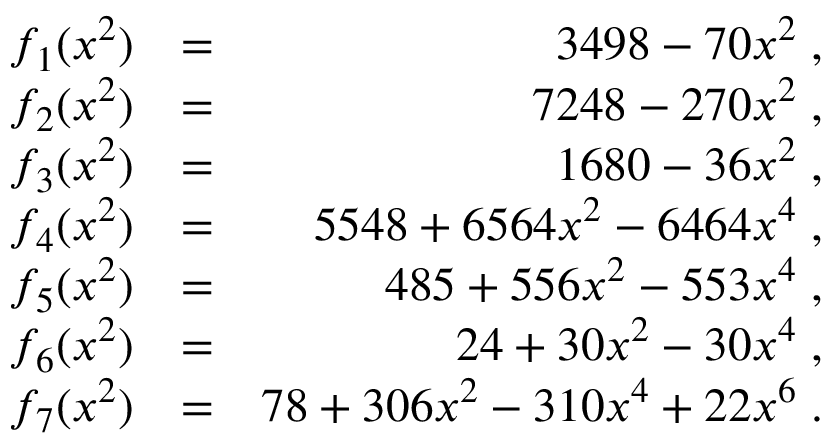<formula> <loc_0><loc_0><loc_500><loc_500>\begin{array} { r l r } { f _ { 1 } ( x ^ { 2 } ) } & { = } & { 3 4 9 8 - 7 0 x ^ { 2 } \, , } \\ { f _ { 2 } ( x ^ { 2 } ) } & { = } & { 7 2 4 8 - 2 7 0 x ^ { 2 } \, , } \\ { f _ { 3 } ( x ^ { 2 } ) } & { = } & { 1 6 8 0 - 3 6 x ^ { 2 } \, , } \\ { f _ { 4 } ( x ^ { 2 } ) } & { = } & { 5 5 4 8 + 6 5 6 4 x ^ { 2 } - 6 4 6 4 x ^ { 4 } \, , } \\ { f _ { 5 } ( x ^ { 2 } ) } & { = } & { 4 8 5 + 5 5 6 x ^ { 2 } - 5 5 3 x ^ { 4 } \, , } \\ { f _ { 6 } ( x ^ { 2 } ) } & { = } & { 2 4 + 3 0 x ^ { 2 } - 3 0 x ^ { 4 } \, , } \\ { f _ { 7 } ( x ^ { 2 } ) } & { = } & { 7 8 + 3 0 6 x ^ { 2 } - 3 1 0 x ^ { 4 } + 2 2 x ^ { 6 } \, . } \end{array}</formula> 